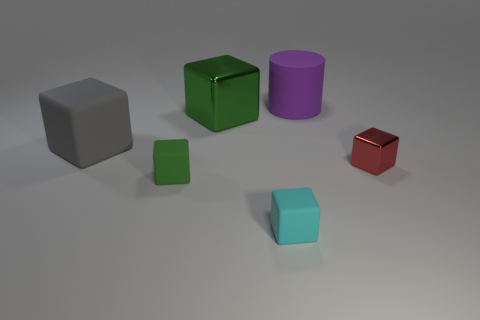There is another block that is the same color as the big metallic cube; what material is it?
Your response must be concise. Rubber. What number of big objects are either cyan rubber blocks or red objects?
Your response must be concise. 0. Is there another rubber cylinder that has the same color as the large matte cylinder?
Make the answer very short. No. What is the shape of the red thing that is the same size as the cyan rubber object?
Offer a terse response. Cube. There is a tiny block that is on the right side of the cylinder; does it have the same color as the large cylinder?
Your answer should be very brief. No. How many things are shiny objects behind the tiny red thing or large matte cubes?
Provide a succinct answer. 2. Is the number of large rubber things to the right of the big green block greater than the number of green things that are behind the big gray cube?
Ensure brevity in your answer.  No. Does the large purple cylinder have the same material as the small cyan object?
Your answer should be compact. Yes. What is the shape of the big object that is on the right side of the tiny green block and in front of the purple rubber object?
Offer a very short reply. Cube. The other big object that is made of the same material as the big purple thing is what shape?
Keep it short and to the point. Cube. 